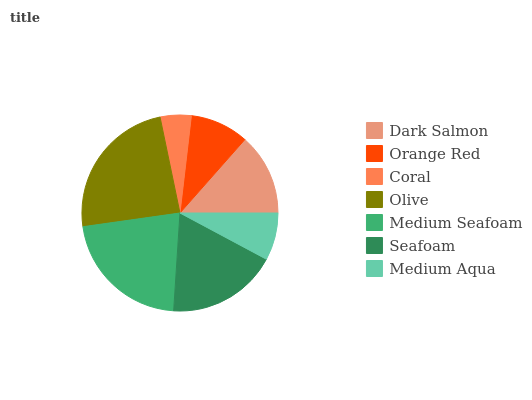Is Coral the minimum?
Answer yes or no. Yes. Is Olive the maximum?
Answer yes or no. Yes. Is Orange Red the minimum?
Answer yes or no. No. Is Orange Red the maximum?
Answer yes or no. No. Is Dark Salmon greater than Orange Red?
Answer yes or no. Yes. Is Orange Red less than Dark Salmon?
Answer yes or no. Yes. Is Orange Red greater than Dark Salmon?
Answer yes or no. No. Is Dark Salmon less than Orange Red?
Answer yes or no. No. Is Dark Salmon the high median?
Answer yes or no. Yes. Is Dark Salmon the low median?
Answer yes or no. Yes. Is Olive the high median?
Answer yes or no. No. Is Coral the low median?
Answer yes or no. No. 